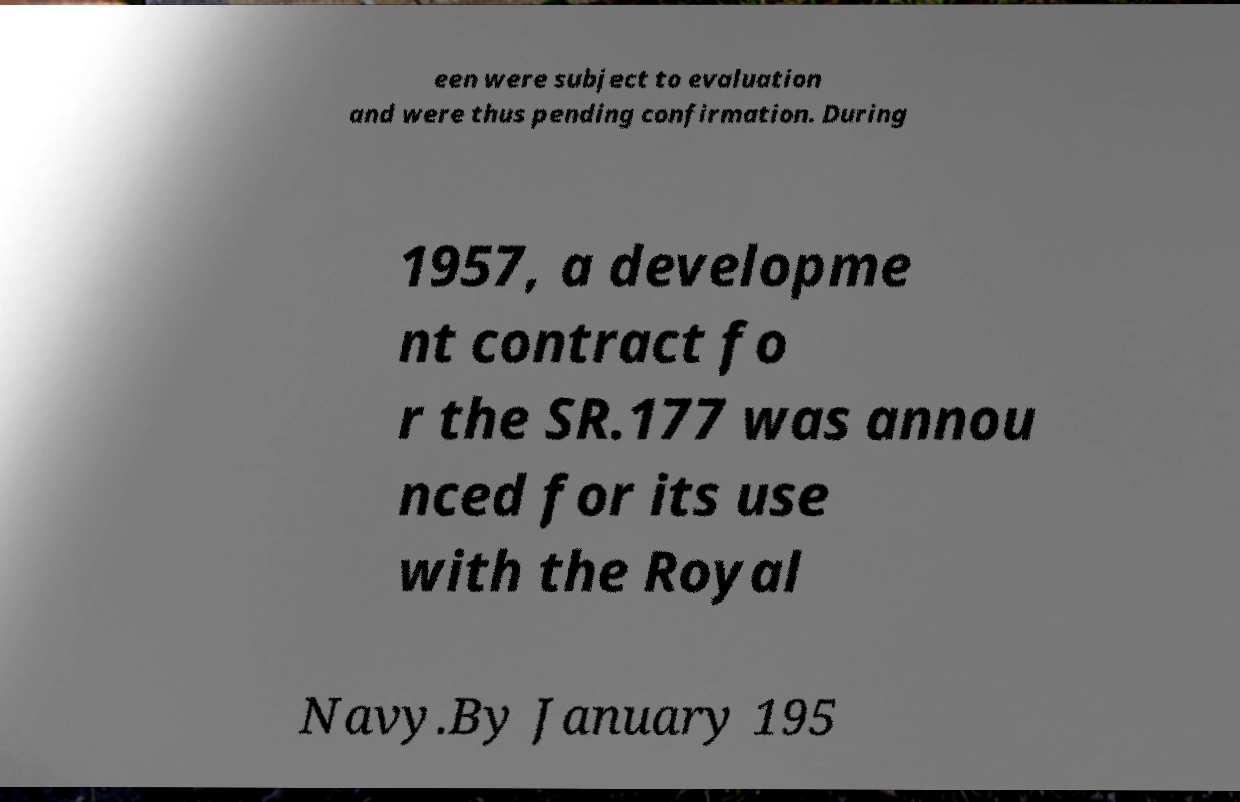Can you read and provide the text displayed in the image?This photo seems to have some interesting text. Can you extract and type it out for me? een were subject to evaluation and were thus pending confirmation. During 1957, a developme nt contract fo r the SR.177 was annou nced for its use with the Royal Navy.By January 195 